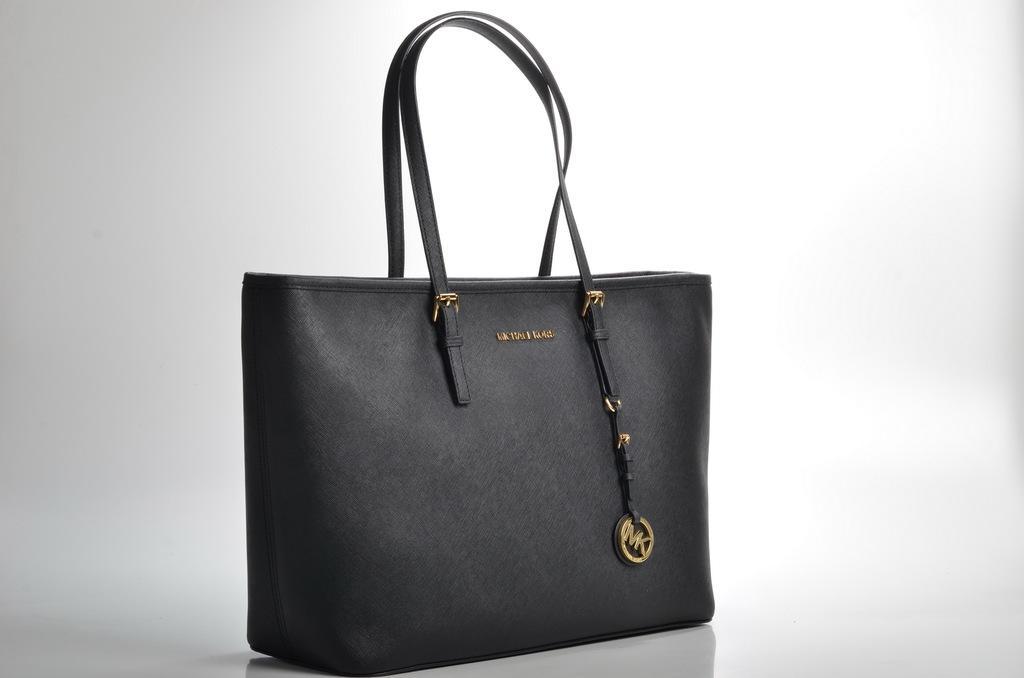Describe this image in one or two sentences. In the center we can see handbag,which is in black color. 